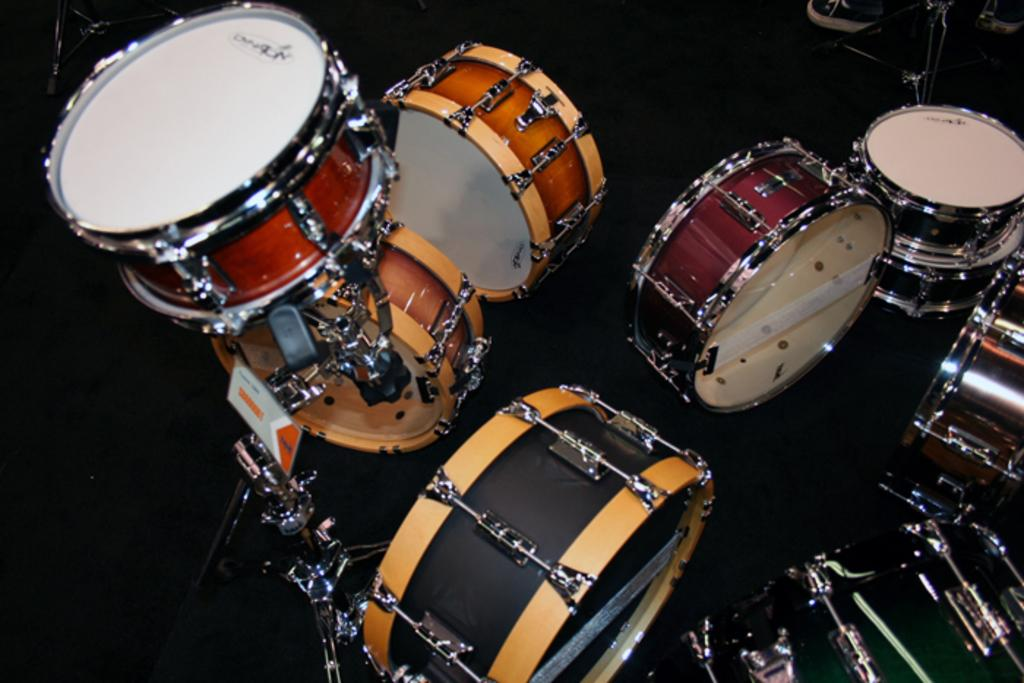What type of objects can be seen in the image? There are musical instruments in the image. What can be seen below the musical instruments? The ground is visible in the image. Are there any objects in the top right corner of the image? Yes, there are objects in the top right corner of the image. Can you describe the action of the toad in the image? There is no toad present in the image, so it is not possible to describe any action involving a toad. 